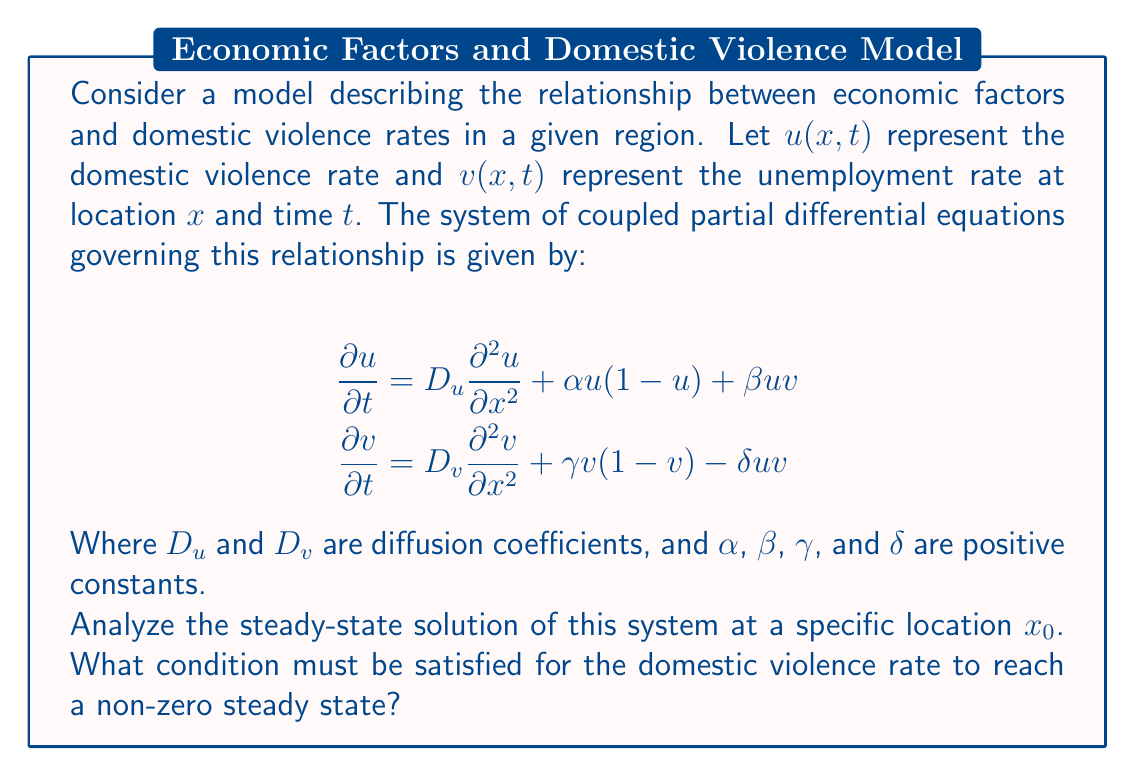Solve this math problem. To analyze the steady-state solution, we need to set the time derivatives to zero:

$$\begin{aligned}
0 &= D_u \frac{\partial^2 u}{\partial x^2} + \alpha u(1-u) + \beta uv \\
0 &= D_v \frac{\partial^2 v}{\partial x^2} + \gamma v(1-v) - \delta uv
\end{aligned}$$

At a specific location $x_0$, we can assume that the spatial derivatives are negligible, simplifying our equations to:

$$\begin{aligned}
0 &= \alpha u(1-u) + \beta uv \\
0 &= \gamma v(1-v) - \delta uv
\end{aligned}$$

For a non-zero steady state of domestic violence rate, we need $u \neq 0$. Let's factor out $u$ from the first equation:

$$u(\alpha(1-u) + \beta v) = 0$$

For $u \neq 0$, we must have:

$$\alpha(1-u) + \beta v = 0$$

Solving for $v$:

$$v = \frac{\alpha(u-1)}{\beta}$$

Substituting this into the second equation:

$$0 = \gamma \frac{\alpha(u-1)}{\beta}(1-\frac{\alpha(u-1)}{\beta}) - \delta u\frac{\alpha(u-1)}{\beta}$$

Simplifying and rearranging:

$$0 = \gamma \alpha (u-1)(\beta - \alpha(u-1)) - \delta \alpha u(u-1)$$

$$0 = (u-1)[\gamma \alpha \beta - \gamma \alpha^2(u-1) - \delta \alpha u]$$

For a non-zero steady state, we need $u \neq 1$, so:

$$\gamma \alpha \beta - \gamma \alpha^2(u-1) - \delta \alpha u = 0$$

Solving for $u$:

$$u = \frac{\gamma \alpha \beta + \gamma \alpha^2}{\gamma \alpha^2 + \delta \alpha}$$

For this steady state to be positive and less than 1, we must have:

$$0 < \frac{\gamma \alpha \beta + \gamma \alpha^2}{\gamma \alpha^2 + \delta \alpha} < 1$$

Simplifying the right inequality:

$$\gamma \alpha \beta + \gamma \alpha^2 < \gamma \alpha^2 + \delta \alpha$$

$$\gamma \alpha \beta < \delta \alpha$$

$$\gamma \beta < \delta$$

This is the condition that must be satisfied for a non-zero steady state of domestic violence rate.
Answer: The condition for a non-zero steady state of domestic violence rate is $\gamma \beta < \delta$, where $\gamma$, $\beta$, and $\delta$ are positive constants in the model representing the growth rate of unemployment, the impact of unemployment on domestic violence, and the reduction in unemployment due to domestic violence, respectively. 